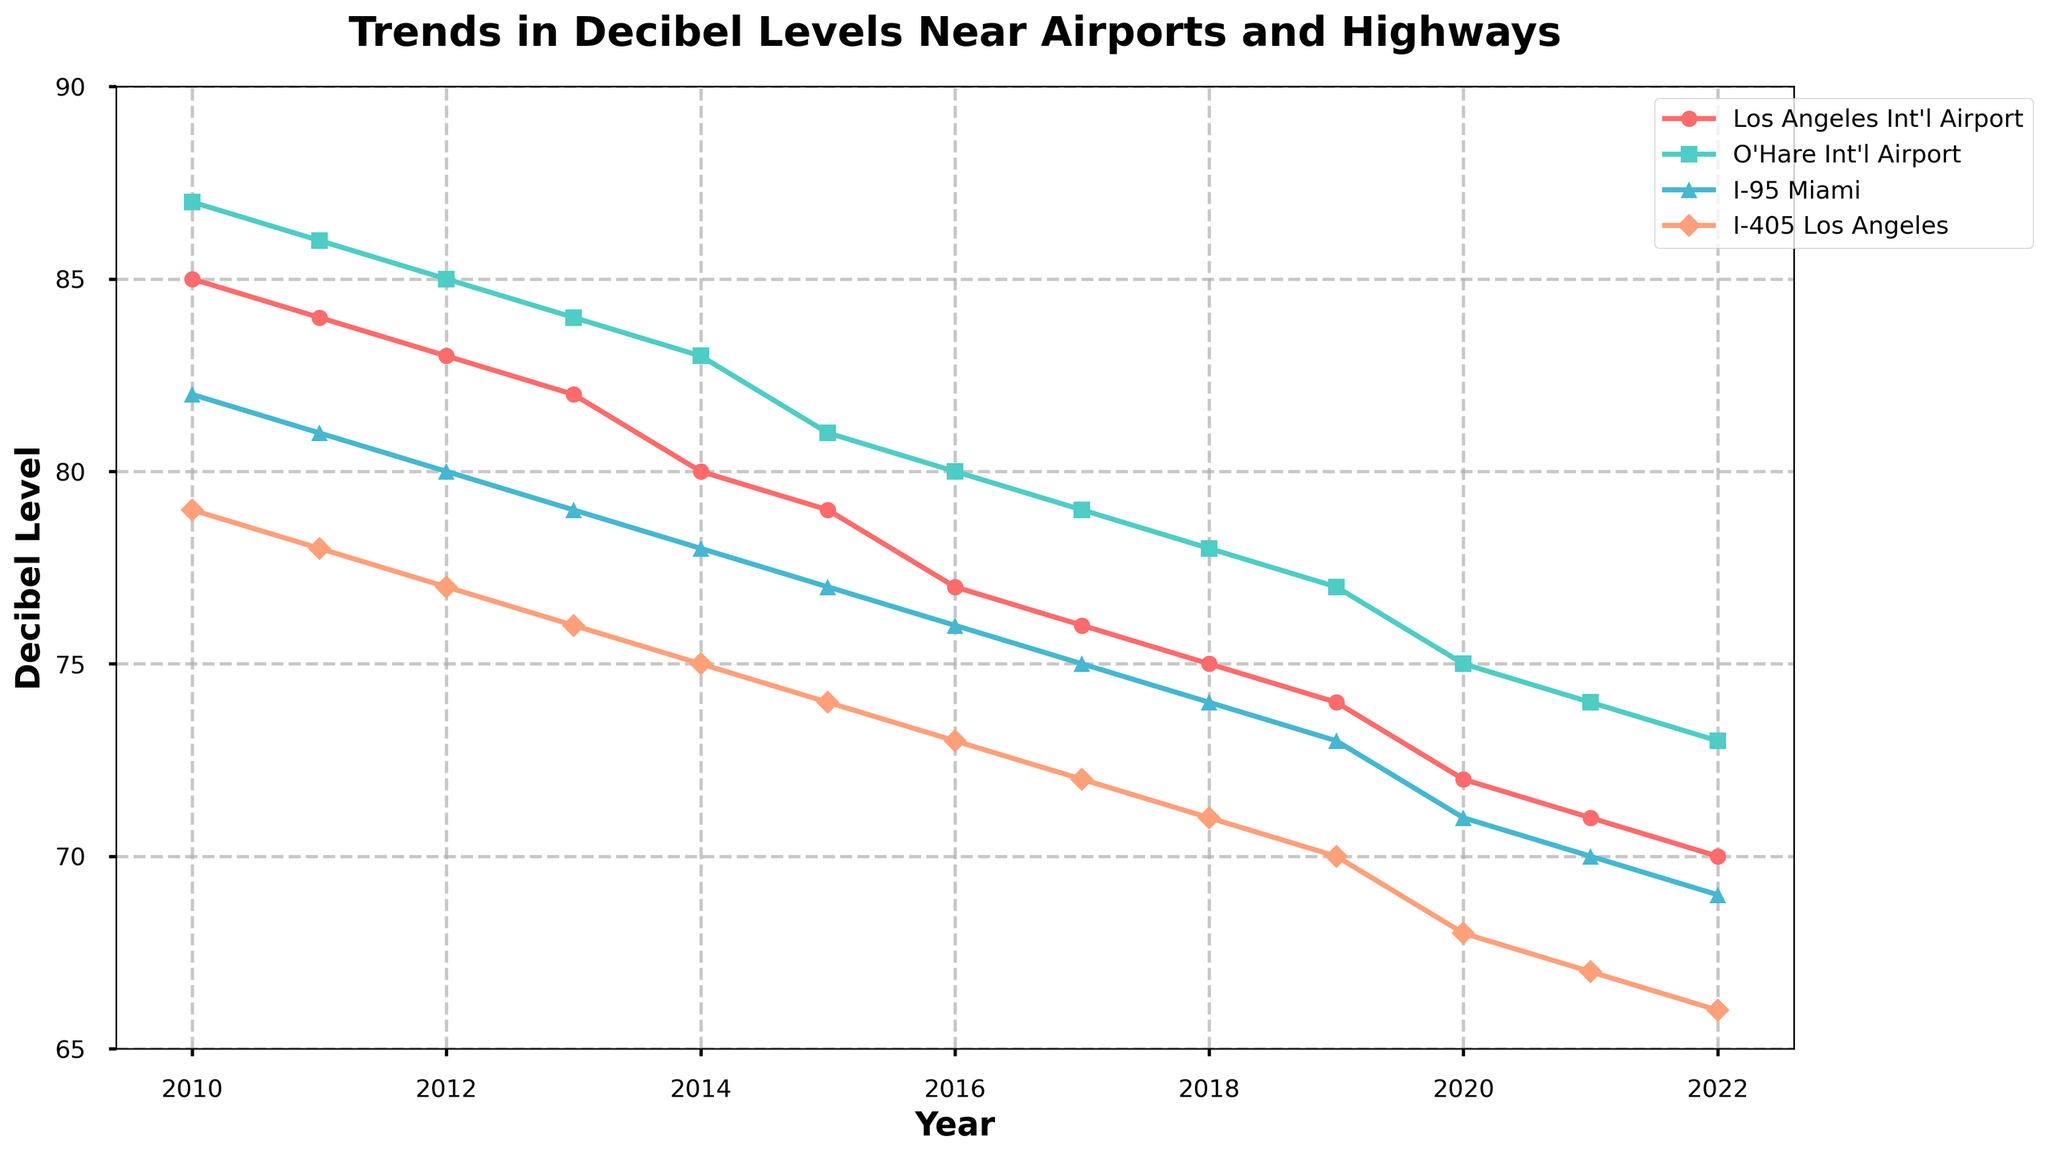What is the trend in decibel levels at the Los Angeles International Airport (LAX) from 2010 to 2022? The decibel levels at LAX show a consistent decreasing trend over the years. Starting from 85 dB in 2010, it gradually decreases to 70 dB by 2022. This indicates a consistent reduction in noise levels.
Answer: Consistent decrease How do the decibel levels in 2010 compare between the O'Hare International Airport (ORD) and I-95 Miami? In 2010, the decibel level at ORD is 87 dB, while at I-95 Miami, it is 82 dB. ORD has a higher noise level compared to I-95 Miami.
Answer: ORD is higher What is the difference in decibel levels between 2015 and 2020 for I-405 Los Angeles? The decibel level in 2015 for I-405 Los Angeles is 74 dB, and in 2020, it is 68 dB. The difference is calculated as 74 - 68 = 6 dB.
Answer: 6 dB Which location showed the greatest reduction in decibel levels from 2010 to 2022? To find the greatest reduction, we subtract the 2022 levels from the 2010 levels for each location:
- LAX: 85 - 70 = 15 dB
- ORD: 87 - 73 = 14 dB
- I-95 Miami: 82 - 69 = 13 dB
- I-405 Los Angeles: 79 - 66 = 13 dB
LAX has the greatest reduction with 15 dB.
Answer: LAX In which year do LAX and I-95 Miami have the same decibel level, and what is that level? By examining the data, both LAX and I-95 Miami have the same decibel level in 2015, which is 77 dB.
Answer: 2015, 77 dB On the plot, which color represents O'Hare International Airport (ORD)? The color coding for ORD is the second in the sequence, which is green. This corresponds to the line representing O'Hare International Airport.
Answer: Green How have the decibel levels at I-405 Los Angeles changed relative to LAX's changes over the entire period? Both LAX and I-405 Los Angeles show a consistent decrease in decibel levels. However, while LAX's noise levels reduced by 15 dB, I-405 Los Angeles's levels reduced by 13 dB from 2010 to 2022.
Answer: Both decreased, LAX more What is the average decibel level for O'Hare International Airport (ORD) across the entire period? To find the average, add the decibel levels for each year and divide by the number of years (13).
(87 + 86 + 85 + 84 + 83 + 81 + 80 + 79 + 78 + 77 + 75 + 74 + 73) / 13 = 81.38 dB.
Answer: 81.38 dB Between which years did I-95 Miami experience the most significant drop in decibel levels, and by how much? To find the most significant drop, compare year-on-year decreases:
2010-2011: 1 dB
2011-2012: 1 dB
2012-2013: 1 dB
2013-2014: 1 dB
2014-2015: 1 dB
2015-2016: 1 dB
2016-2017: 1 dB
2017-2018: 1 dB
2018-2019: 1 dB
2019-2020: 2 dB
2020-2021: 1 dB
2021-2022: 1 dB
The most significant drop is between 2019 and 2020 by 2 dB.
Answer: 2019-2020, 2 dB Do all locations exhibit the same trend in decibel levels before and after 2015? Before 2015, all locations show a consistent reduction in decibel levels. This trend continues similarly after 2015 for all locations, indicating uniform implementation of noise reduction measures.
Answer: Yes 